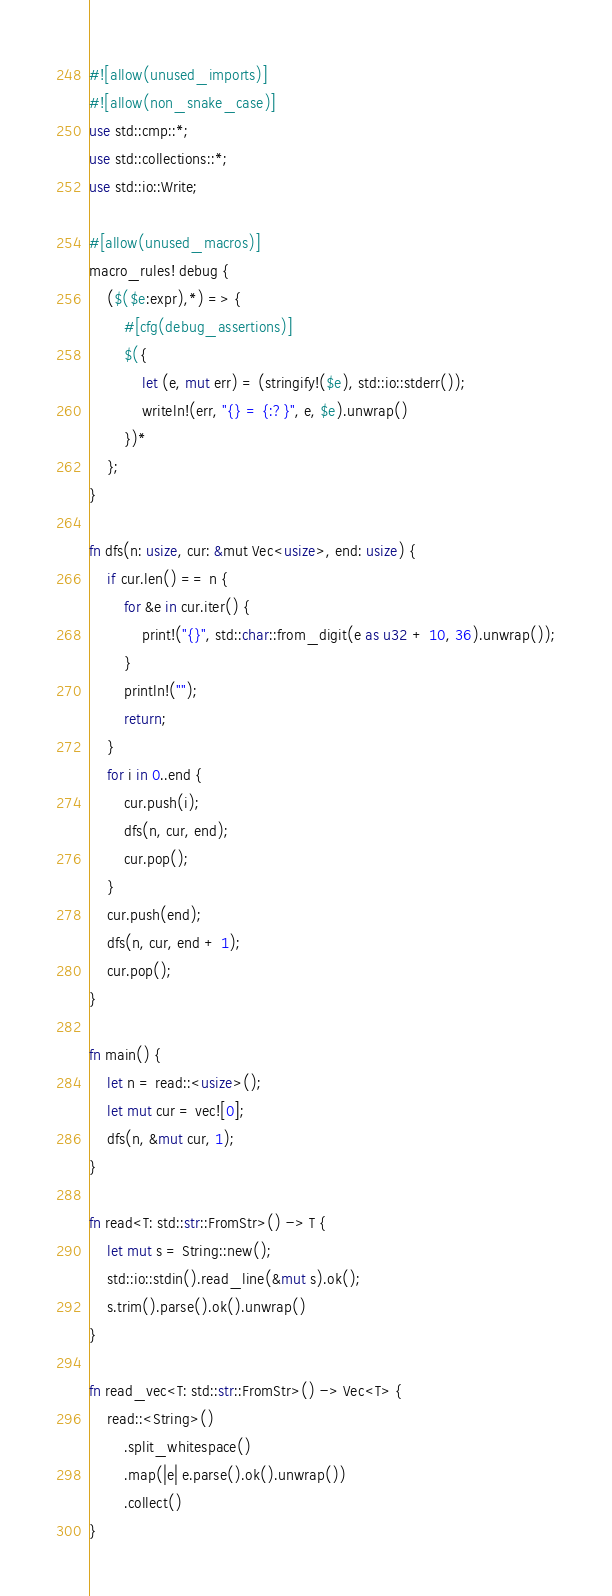Convert code to text. <code><loc_0><loc_0><loc_500><loc_500><_Rust_>#![allow(unused_imports)]
#![allow(non_snake_case)]
use std::cmp::*;
use std::collections::*;
use std::io::Write;

#[allow(unused_macros)]
macro_rules! debug {
    ($($e:expr),*) => {
        #[cfg(debug_assertions)]
        $({
            let (e, mut err) = (stringify!($e), std::io::stderr());
            writeln!(err, "{} = {:?}", e, $e).unwrap()
        })*
    };
}

fn dfs(n: usize, cur: &mut Vec<usize>, end: usize) {
    if cur.len() == n {
        for &e in cur.iter() {
            print!("{}", std::char::from_digit(e as u32 + 10, 36).unwrap());
        }
        println!("");
        return;
    }
    for i in 0..end {
        cur.push(i);
        dfs(n, cur, end);
        cur.pop();
    }
    cur.push(end);
    dfs(n, cur, end + 1);
    cur.pop();
}

fn main() {
    let n = read::<usize>();
    let mut cur = vec![0];
    dfs(n, &mut cur, 1);
}

fn read<T: std::str::FromStr>() -> T {
    let mut s = String::new();
    std::io::stdin().read_line(&mut s).ok();
    s.trim().parse().ok().unwrap()
}

fn read_vec<T: std::str::FromStr>() -> Vec<T> {
    read::<String>()
        .split_whitespace()
        .map(|e| e.parse().ok().unwrap())
        .collect()
}
</code> 